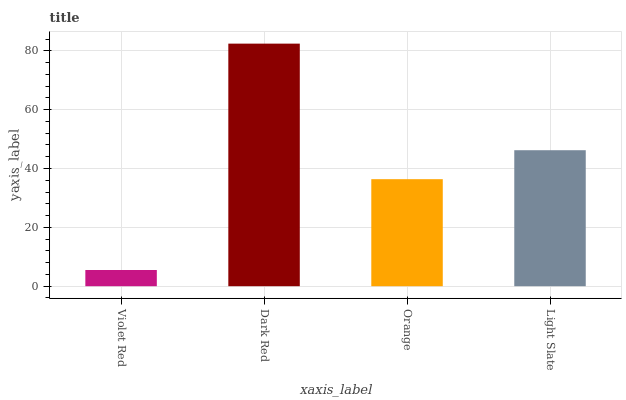Is Orange the minimum?
Answer yes or no. No. Is Orange the maximum?
Answer yes or no. No. Is Dark Red greater than Orange?
Answer yes or no. Yes. Is Orange less than Dark Red?
Answer yes or no. Yes. Is Orange greater than Dark Red?
Answer yes or no. No. Is Dark Red less than Orange?
Answer yes or no. No. Is Light Slate the high median?
Answer yes or no. Yes. Is Orange the low median?
Answer yes or no. Yes. Is Orange the high median?
Answer yes or no. No. Is Violet Red the low median?
Answer yes or no. No. 